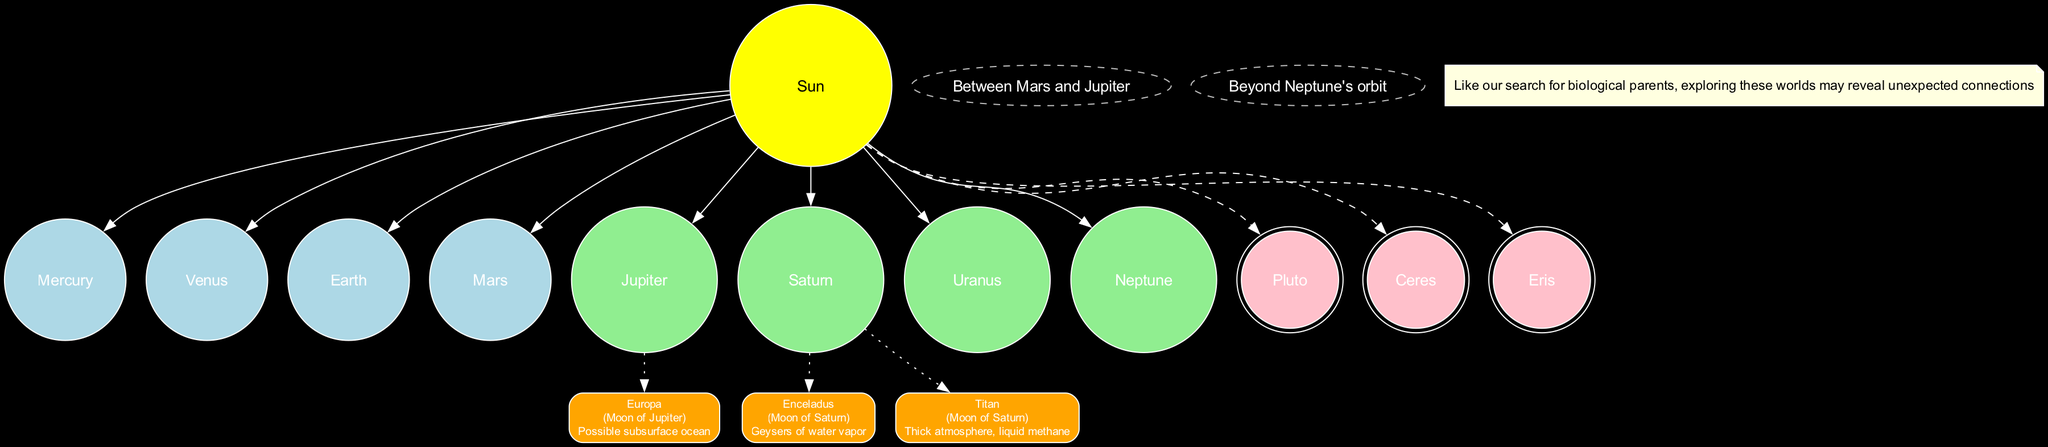What are the inner planets? The inner planets, which are closest to the Sun, are explicitly listed in the diagram. They include Mercury, Venus, Earth, and Mars.
Answer: Mercury, Venus, Earth, Mars How many dwarf planets are there? The diagram clearly shows a section for dwarf planets, where three are listed: Pluto, Ceres, and Eris. Therefore, the total number is three.
Answer: 3 What type of celestial body is Europa? The diagram denotes Europa as a moon of Jupiter, which is noted alongside the specific characteristics related to its potential for a subsurface ocean.
Answer: Moon of Jupiter Which planet has potential habitats mentioned? The habitat nodes connected to the diagram are linked to Jupiter and Saturn; specifically, Europa is related to Jupiter, while Enceladus and Titan are associated with Saturn, indicating that Saturn has habitats mentioned.
Answer: Saturn What is located between Mars and Jupiter? The diagram indicates a specific section for the asteroid belt, which is described as being located between the orbits of Mars and Jupiter.
Answer: Asteroid Belt Which dwarf planet is represented by a double circle? The diagram uses a double-circle shape exclusively for denoting dwarf planets, which include Pluto, Ceres, and Eris. As per the visualization, Pluto specifically is represented this way.
Answer: Pluto How many notable moons with potential Earth-like conditions are shown? The potential habitats section of the diagram lists three notable moons: Europa, Enceladus, and Titan, confirming that there are three moons indicated as having the potential for Earth-like conditions.
Answer: 3 What color represents the Sun in this diagram? The diagram distinctly colors the node for the Sun in yellow, indicating its unique position and significance at the center of the solar system structure.
Answer: Yellow Which belt is located beyond Neptune's orbit? The diagram specifies a node indicating the Kuiper Belt, which is explicitly stated to be located beyond the orbit of Neptune.
Answer: Kuiper Belt 